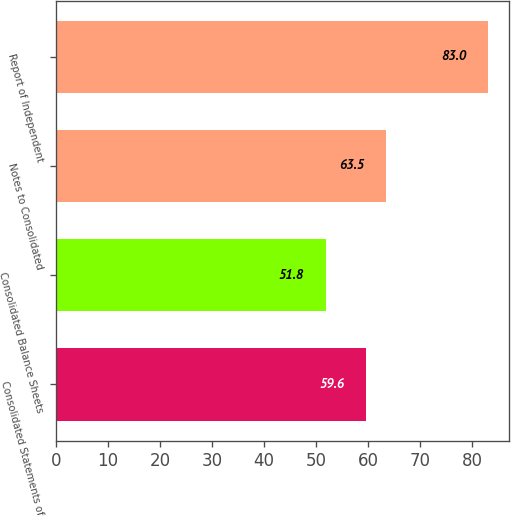Convert chart to OTSL. <chart><loc_0><loc_0><loc_500><loc_500><bar_chart><fcel>Consolidated Statements of<fcel>Consolidated Balance Sheets<fcel>Notes to Consolidated<fcel>Report of Independent<nl><fcel>59.6<fcel>51.8<fcel>63.5<fcel>83<nl></chart> 